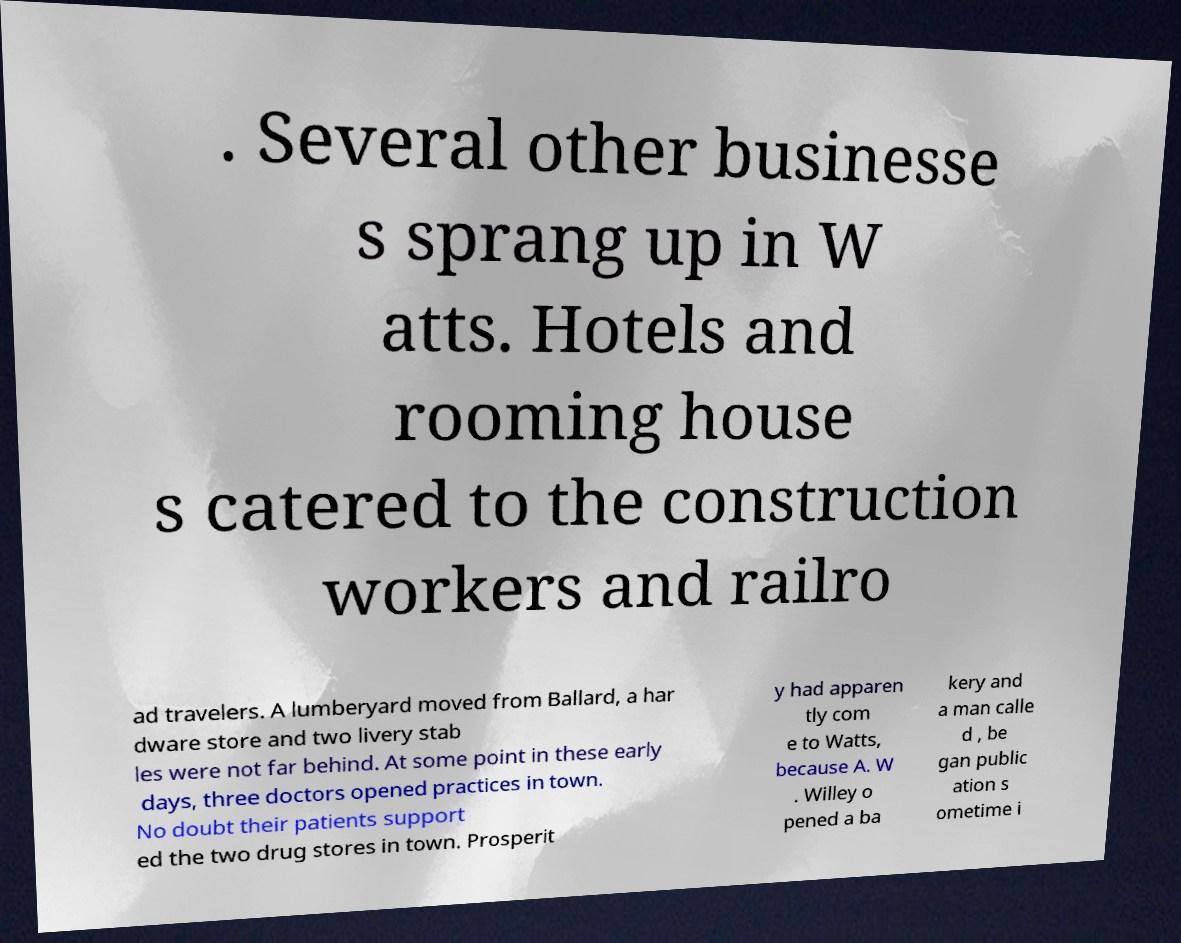Can you read and provide the text displayed in the image?This photo seems to have some interesting text. Can you extract and type it out for me? . Several other businesse s sprang up in W atts. Hotels and rooming house s catered to the construction workers and railro ad travelers. A lumberyard moved from Ballard, a har dware store and two livery stab les were not far behind. At some point in these early days, three doctors opened practices in town. No doubt their patients support ed the two drug stores in town. Prosperit y had apparen tly com e to Watts, because A. W . Willey o pened a ba kery and a man calle d , be gan public ation s ometime i 